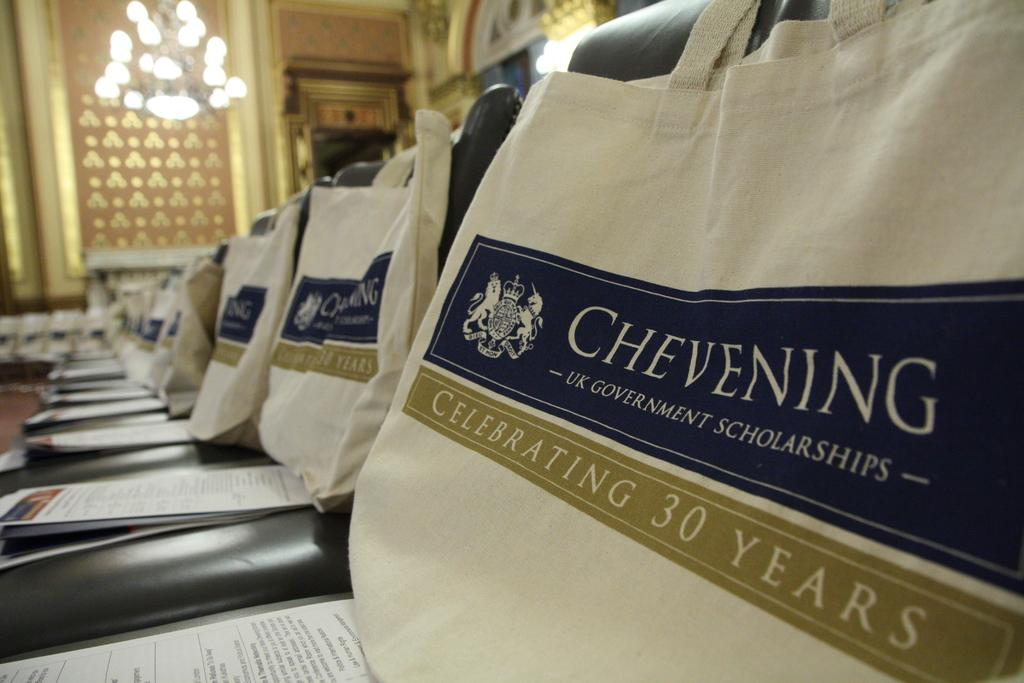Provide a one-sentence caption for the provided image. Multiple bags and pamphlets  from the brand Chevening are on top of chairs. 